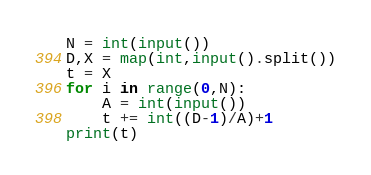<code> <loc_0><loc_0><loc_500><loc_500><_Python_>N = int(input())
D,X = map(int,input().split())
t = X
for i in range(0,N):
    A = int(input())
    t += int((D-1)/A)+1
print(t)</code> 